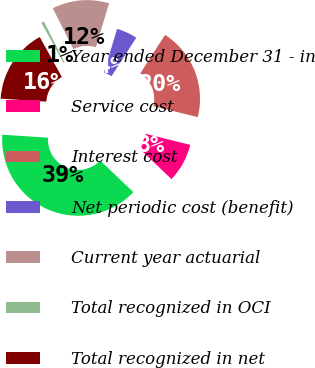Convert chart. <chart><loc_0><loc_0><loc_500><loc_500><pie_chart><fcel>Year ended December 31 - in<fcel>Service cost<fcel>Interest cost<fcel>Net periodic cost (benefit)<fcel>Current year actuarial<fcel>Total recognized in OCI<fcel>Total recognized in net<nl><fcel>38.92%<fcel>8.26%<fcel>19.76%<fcel>4.43%<fcel>12.1%<fcel>0.6%<fcel>15.93%<nl></chart> 